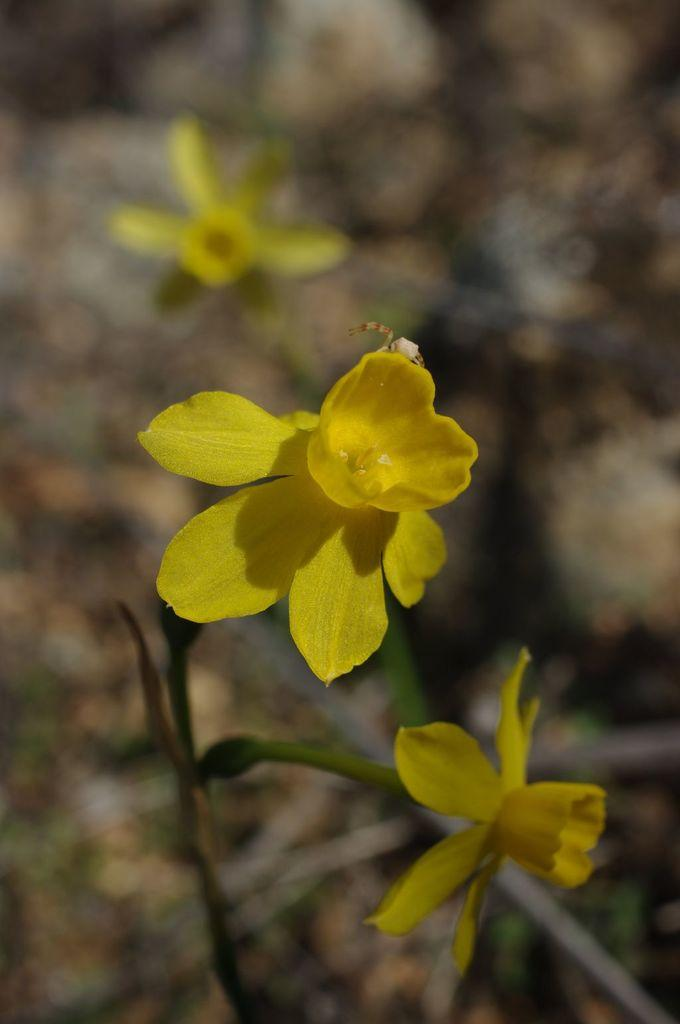Where was the image taken? The image is taken outdoors. What can be seen in the background of the image? There is a ground visible in the background. What is the main subject of the image? There is a plant in the middle of the image. What color are the flowers on the plant? The plant has yellow flowers. How many sails can be seen on the plant in the image? There are no sails present in the image; it features a plant with yellow flowers. Is there a beggar visible in the image? There is no beggar present in the image; it features a plant with yellow flowers. 